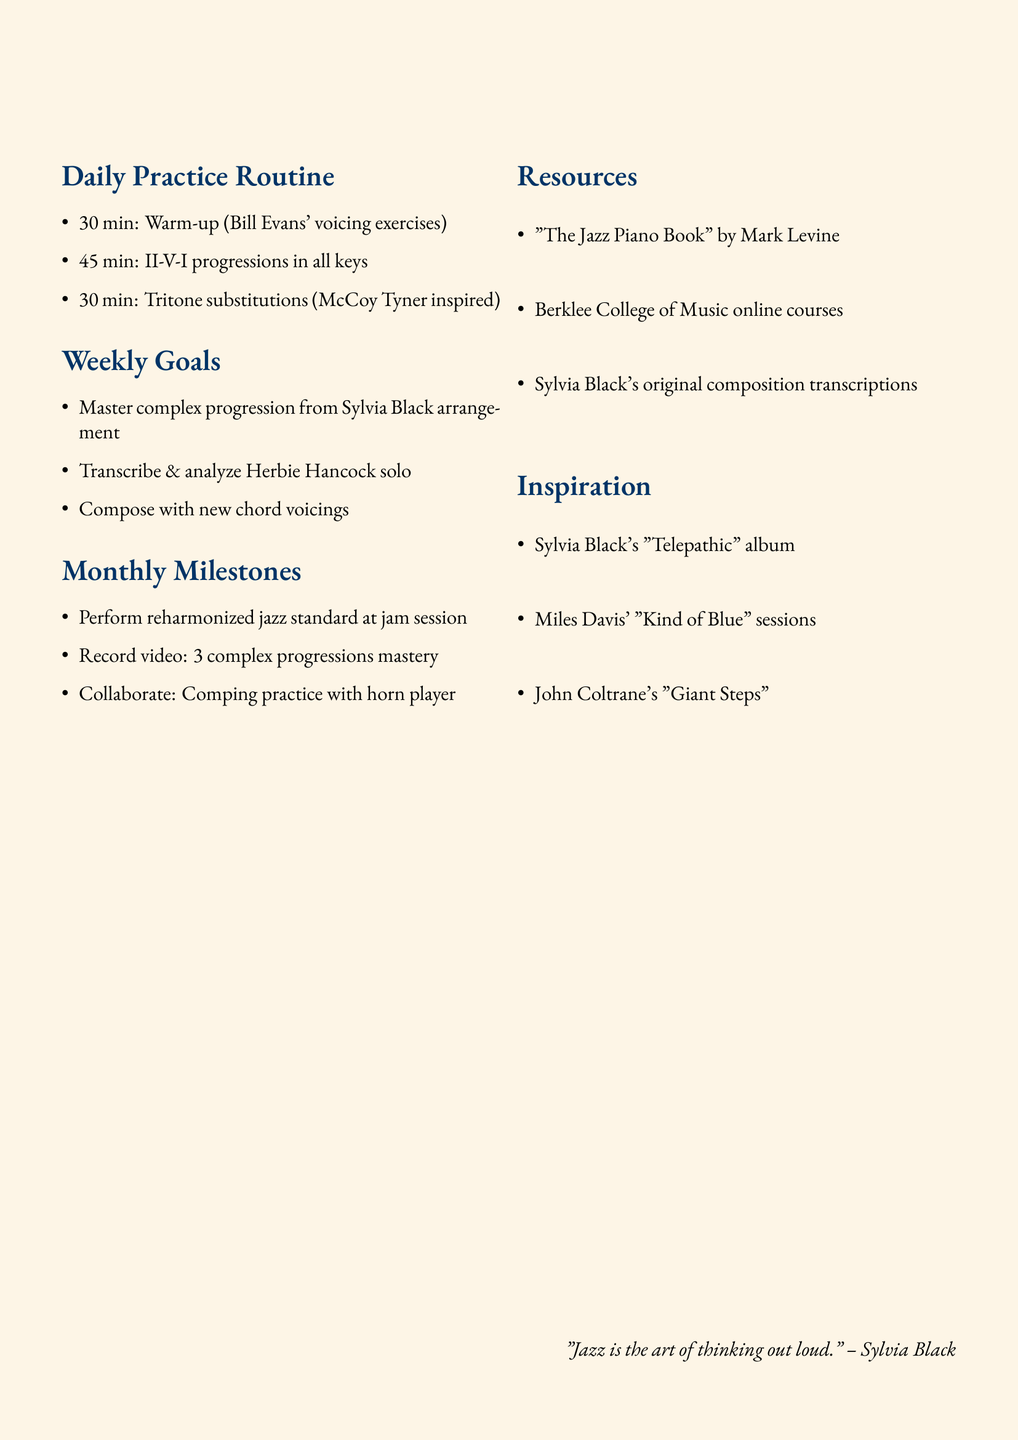What is the first warm-up exercise listed? The first warm-up exercise mentioned in the daily practice routine is "Bill Evans' voicing exercises".
Answer: Bill Evans' voicing exercises How long is dedicated to studying II-V-I progressions? It specifies that 45 minutes is allocated for studying and practicing II-V-I progressions.
Answer: 45 minutes What is one weekly goal mentioned? The document lists several weekly goals, one of which is to "Master one complex progression from a Sylvia Black arrangement".
Answer: Master one complex progression from a Sylvia Black arrangement Where can you find online courses as a resource? The document indicates "Berklee College of Music" as a source for online courses.
Answer: Berklee College of Music What is a monthly milestone to achieve? One of the monthly milestones stated is to "Perform a jazz standard with advanced reharmonization at local jam session".
Answer: Perform a jazz standard with advanced reharmonization at local jam session Which album by Sylvia Black is mentioned for inspiration? The document references Sylvia Black's album titled "Telepathic" for harmonic approaches.
Answer: Telepathic Who is suggested for inspiration from listening to their sessions? The document suggests studying the chord voicings in "Miles Davis' Kind of Blue sessions" for inspiration.
Answer: Miles Davis What is the total time allocated for daily practice? The total time allocated is the sum of all daily practices, which is 30 + 45 + 30 minutes, equating to 105 minutes.
Answer: 105 minutes What is a suggested activity for collaboration? It suggests collaborating with a horn player to practice comping with sophisticated voicings as an activity.
Answer: Comping with sophisticated voicings 